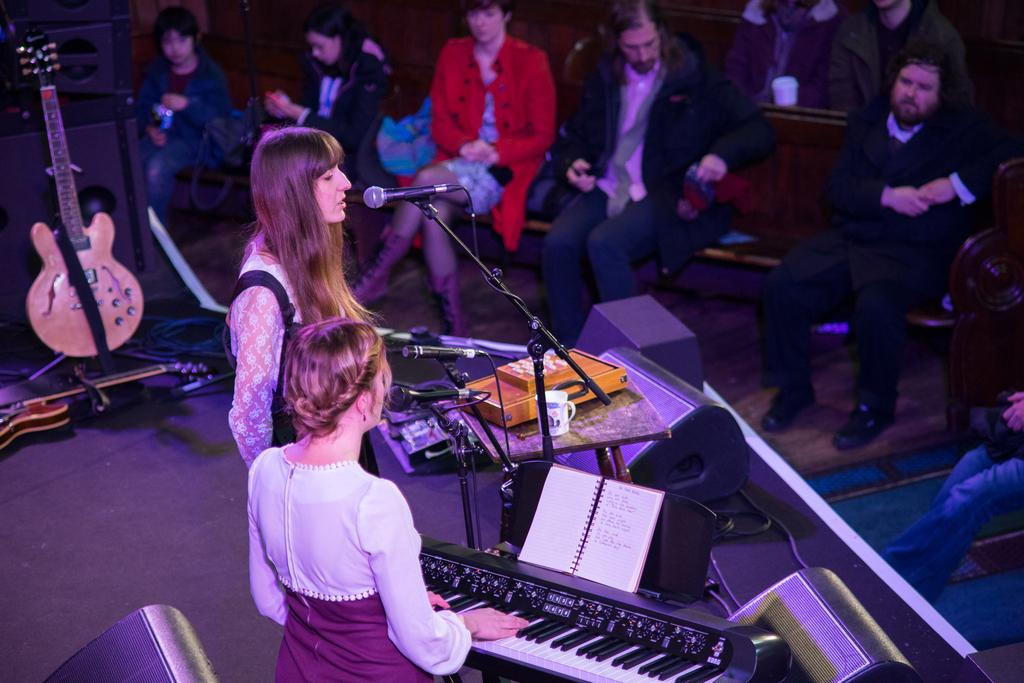What is the woman in the image doing? The woman in the image is singing. What is the woman holding while singing? She is holding a microphone. What is the other woman in the image doing? The other woman is playing a keyboard. Where are the women performing their respective activities? Both women are on a stage. How many bits can be seen in the image? There are no bits present in the image. Is the singing woman being quiet in the image? The singing woman is not being quiet, as she is actively singing in the image. 